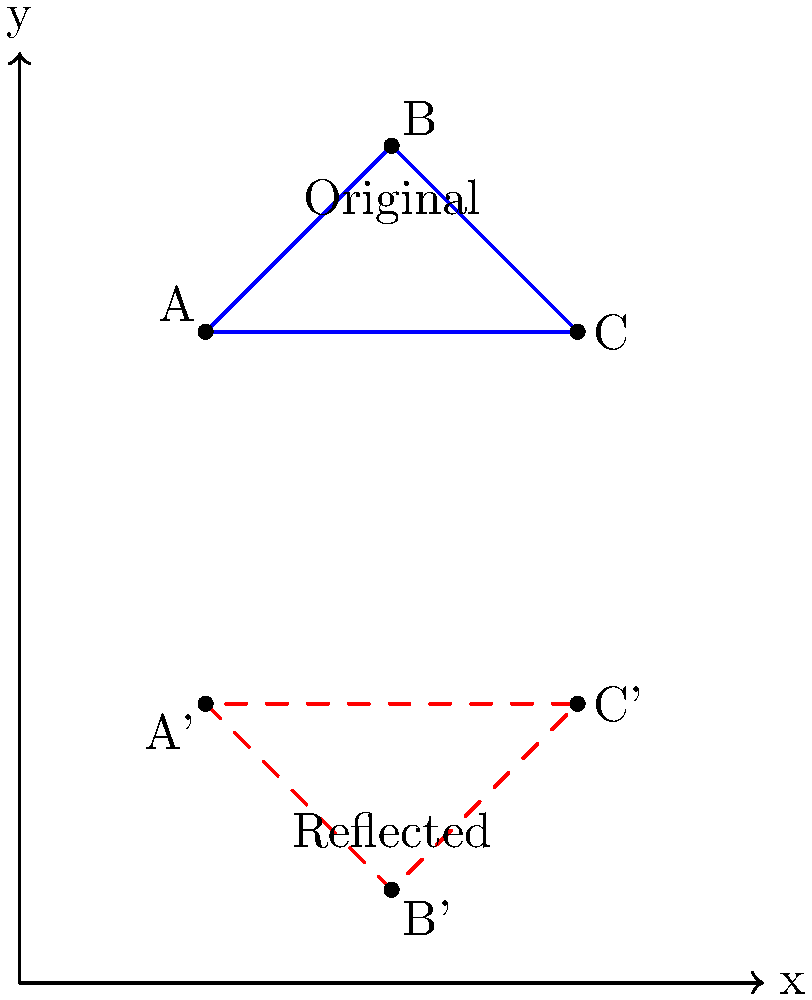In a choreography inspired by geometric transformations, a triangle ABC represents a formation of three dancers. The coordinates of the vertices are A(1,2), B(3,4), and C(5,2). If this formation is reflected across the x-axis to create a mirrored effect, what will be the coordinates of the reflected triangle A'B'C'? To reflect a shape across the x-axis, we keep the x-coordinates the same and negate the y-coordinates. Let's go through this step-by-step:

1) For point A(1,2):
   - x-coordinate remains 1
   - y-coordinate changes from 2 to -2
   So, A' becomes (1,-2)

2) For point B(3,4):
   - x-coordinate remains 3
   - y-coordinate changes from 4 to -4
   So, B' becomes (3,-4)

3) For point C(5,2):
   - x-coordinate remains 5
   - y-coordinate changes from 2 to -2
   So, C' becomes (5,-2)

Therefore, the coordinates of the reflected triangle A'B'C' are:
A'(1,-2), B'(3,-4), and C'(5,-2)

This reflection across the x-axis is similar to how dancers might mirror each other's movements in a pas de deux, with the x-axis acting as an imaginary mirror on the stage floor.
Answer: A'(1,-2), B'(3,-4), C'(5,-2) 